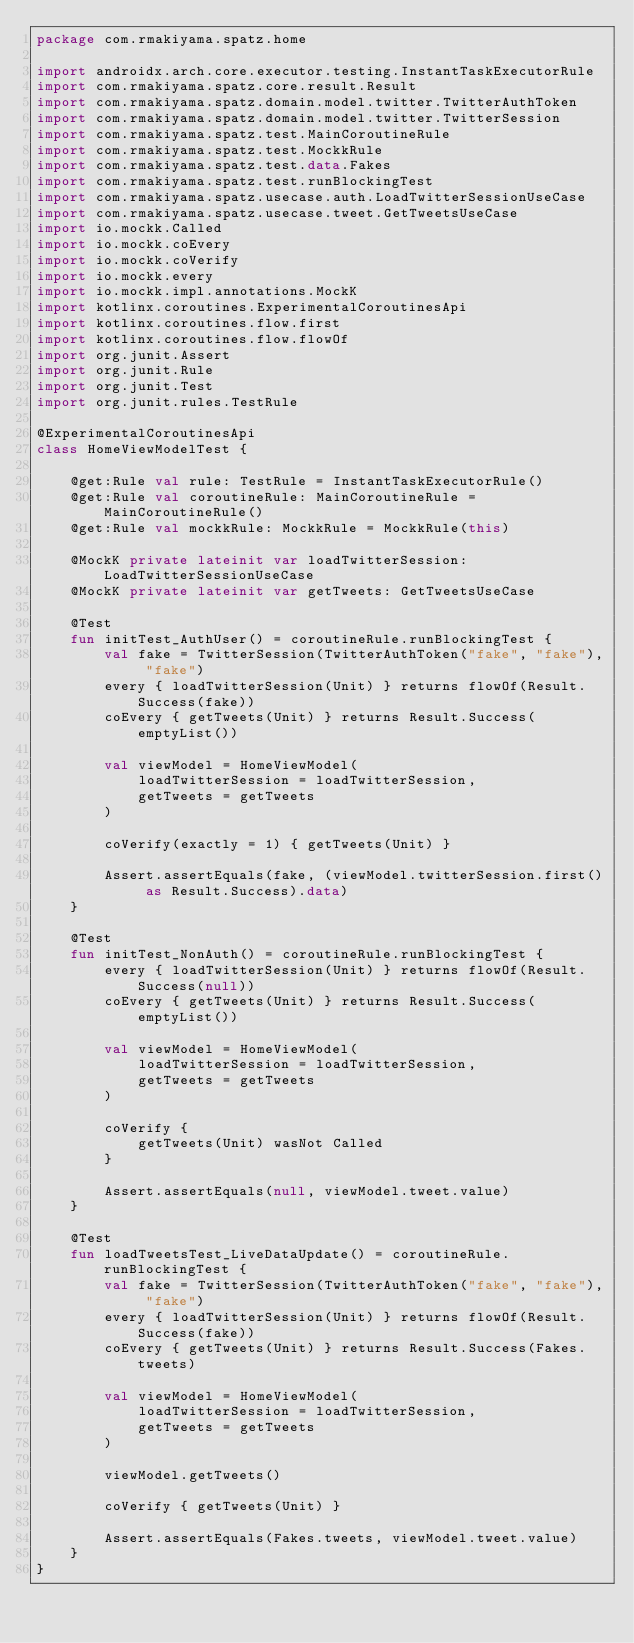Convert code to text. <code><loc_0><loc_0><loc_500><loc_500><_Kotlin_>package com.rmakiyama.spatz.home

import androidx.arch.core.executor.testing.InstantTaskExecutorRule
import com.rmakiyama.spatz.core.result.Result
import com.rmakiyama.spatz.domain.model.twitter.TwitterAuthToken
import com.rmakiyama.spatz.domain.model.twitter.TwitterSession
import com.rmakiyama.spatz.test.MainCoroutineRule
import com.rmakiyama.spatz.test.MockkRule
import com.rmakiyama.spatz.test.data.Fakes
import com.rmakiyama.spatz.test.runBlockingTest
import com.rmakiyama.spatz.usecase.auth.LoadTwitterSessionUseCase
import com.rmakiyama.spatz.usecase.tweet.GetTweetsUseCase
import io.mockk.Called
import io.mockk.coEvery
import io.mockk.coVerify
import io.mockk.every
import io.mockk.impl.annotations.MockK
import kotlinx.coroutines.ExperimentalCoroutinesApi
import kotlinx.coroutines.flow.first
import kotlinx.coroutines.flow.flowOf
import org.junit.Assert
import org.junit.Rule
import org.junit.Test
import org.junit.rules.TestRule

@ExperimentalCoroutinesApi
class HomeViewModelTest {

    @get:Rule val rule: TestRule = InstantTaskExecutorRule()
    @get:Rule val coroutineRule: MainCoroutineRule = MainCoroutineRule()
    @get:Rule val mockkRule: MockkRule = MockkRule(this)

    @MockK private lateinit var loadTwitterSession: LoadTwitterSessionUseCase
    @MockK private lateinit var getTweets: GetTweetsUseCase

    @Test
    fun initTest_AuthUser() = coroutineRule.runBlockingTest {
        val fake = TwitterSession(TwitterAuthToken("fake", "fake"), "fake")
        every { loadTwitterSession(Unit) } returns flowOf(Result.Success(fake))
        coEvery { getTweets(Unit) } returns Result.Success(emptyList())

        val viewModel = HomeViewModel(
            loadTwitterSession = loadTwitterSession,
            getTweets = getTweets
        )

        coVerify(exactly = 1) { getTweets(Unit) }

        Assert.assertEquals(fake, (viewModel.twitterSession.first() as Result.Success).data)
    }

    @Test
    fun initTest_NonAuth() = coroutineRule.runBlockingTest {
        every { loadTwitterSession(Unit) } returns flowOf(Result.Success(null))
        coEvery { getTweets(Unit) } returns Result.Success(emptyList())

        val viewModel = HomeViewModel(
            loadTwitterSession = loadTwitterSession,
            getTweets = getTweets
        )

        coVerify {
            getTweets(Unit) wasNot Called
        }

        Assert.assertEquals(null, viewModel.tweet.value)
    }

    @Test
    fun loadTweetsTest_LiveDataUpdate() = coroutineRule.runBlockingTest {
        val fake = TwitterSession(TwitterAuthToken("fake", "fake"), "fake")
        every { loadTwitterSession(Unit) } returns flowOf(Result.Success(fake))
        coEvery { getTweets(Unit) } returns Result.Success(Fakes.tweets)

        val viewModel = HomeViewModel(
            loadTwitterSession = loadTwitterSession,
            getTweets = getTweets
        )

        viewModel.getTweets()

        coVerify { getTweets(Unit) }

        Assert.assertEquals(Fakes.tweets, viewModel.tweet.value)
    }
}
</code> 